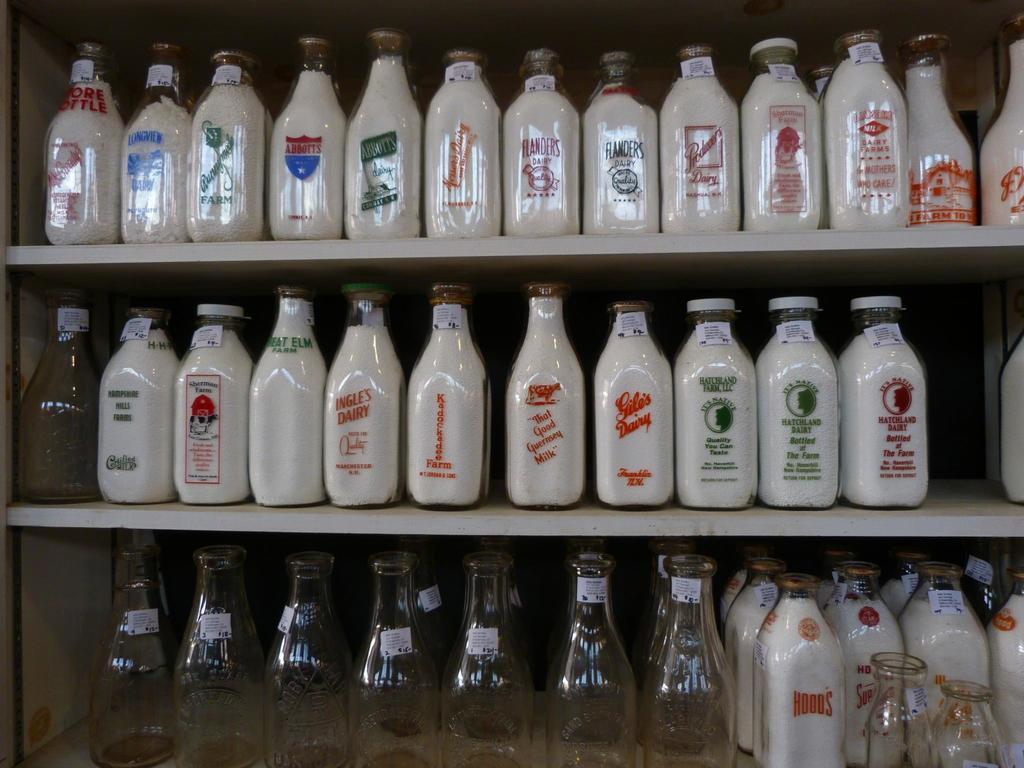<image>
Summarize the visual content of the image. Many milk bottles on a shelf with one on the middle shelf by Kadockadee Farms. 